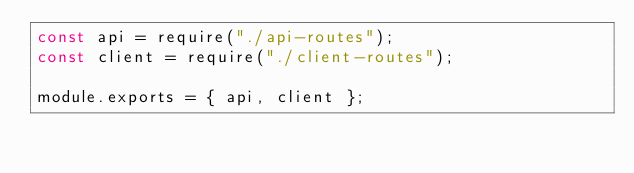<code> <loc_0><loc_0><loc_500><loc_500><_JavaScript_>const api = require("./api-routes");
const client = require("./client-routes");

module.exports = { api, client };
</code> 